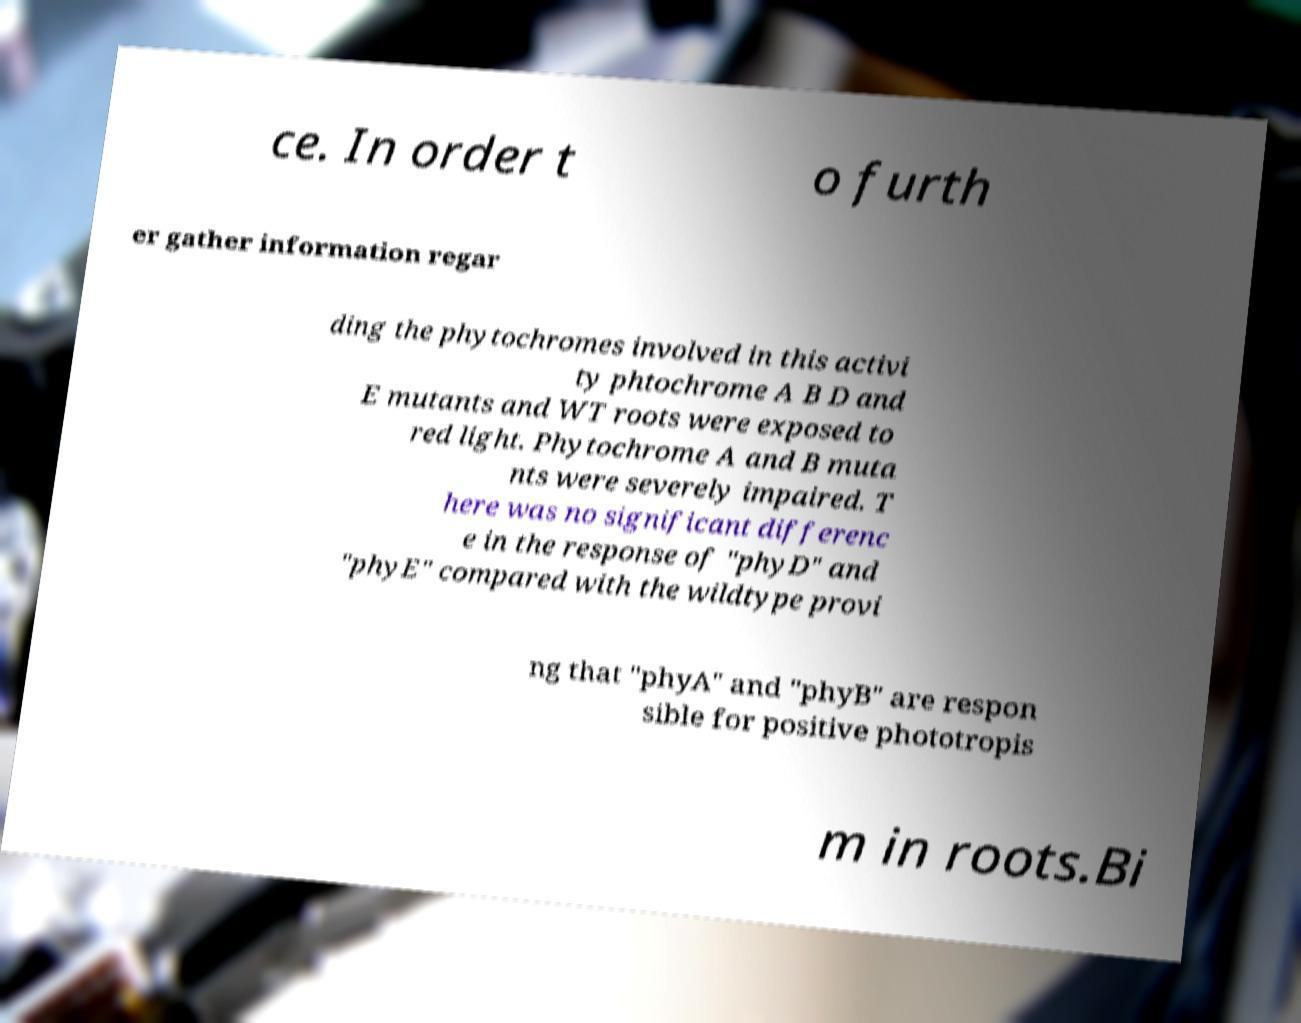There's text embedded in this image that I need extracted. Can you transcribe it verbatim? ce. In order t o furth er gather information regar ding the phytochromes involved in this activi ty phtochrome A B D and E mutants and WT roots were exposed to red light. Phytochrome A and B muta nts were severely impaired. T here was no significant differenc e in the response of "phyD" and "phyE" compared with the wildtype provi ng that "phyA" and "phyB" are respon sible for positive phototropis m in roots.Bi 